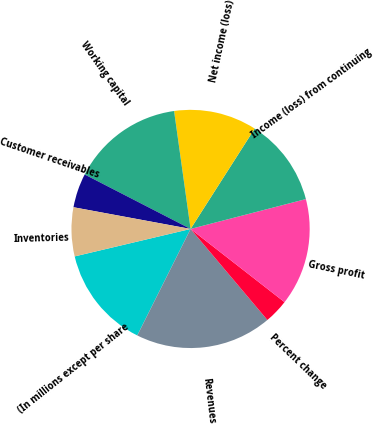Convert chart. <chart><loc_0><loc_0><loc_500><loc_500><pie_chart><fcel>(In millions except per share<fcel>Revenues<fcel>Percent change<fcel>Gross profit<fcel>Income (loss) from continuing<fcel>Net income (loss)<fcel>Working capital<fcel>Customer receivables<fcel>Inventories<nl><fcel>13.91%<fcel>18.54%<fcel>3.31%<fcel>14.57%<fcel>11.92%<fcel>11.26%<fcel>15.23%<fcel>4.64%<fcel>6.62%<nl></chart> 